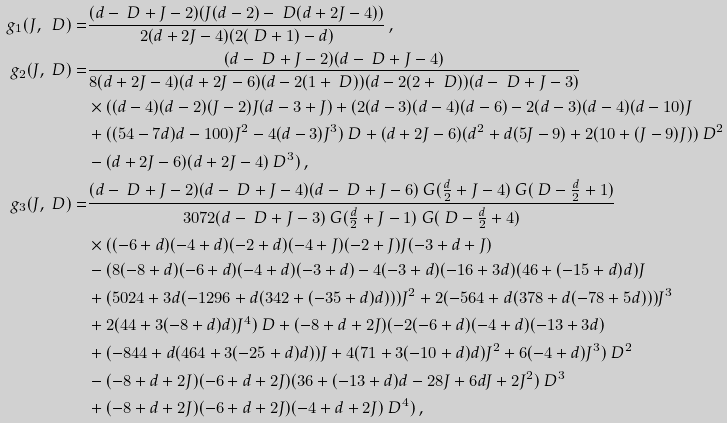Convert formula to latex. <formula><loc_0><loc_0><loc_500><loc_500>g _ { 1 } ( J , \ D ) = & \frac { ( d - \ D + J - 2 ) ( J ( d - 2 ) - \ D ( d + 2 J - 4 ) ) } { 2 ( d + 2 J - 4 ) ( 2 ( \ D + 1 ) - d ) } \, , \\ g _ { 2 } ( J , \ D ) = & \frac { ( d - \ D + J - 2 ) ( d - \ D + J - 4 ) } { 8 ( d + 2 J - 4 ) ( d + 2 J - 6 ) ( d - 2 ( 1 + \ D ) ) ( d - 2 ( 2 + \ D ) ) ( d - \ D + J - 3 ) } \\ & \times ( ( d - 4 ) ( d - 2 ) ( J - 2 ) J ( d - 3 + J ) + ( 2 ( d - 3 ) ( d - 4 ) ( d - 6 ) - 2 ( d - 3 ) ( d - 4 ) ( d - 1 0 ) J \\ & + ( ( 5 4 - 7 d ) d - 1 0 0 ) J ^ { 2 } - 4 ( d - 3 ) J ^ { 3 } ) \ D + ( d + 2 J - 6 ) ( d ^ { 2 } + d ( 5 J - 9 ) + 2 ( 1 0 + ( J - 9 ) J ) ) \ D ^ { 2 } \\ & - ( d + 2 J - 6 ) ( d + 2 J - 4 ) \ D ^ { 3 } ) \, , \\ g _ { 3 } ( J , \ D ) = & \frac { ( d - \ D + J - 2 ) ( d - \ D + J - 4 ) ( d - \ D + J - 6 ) \ G ( \frac { d } { 2 } + J - 4 ) \ G ( \ D - \frac { d } { 2 } + 1 ) } { 3 0 7 2 ( d - \ D + J - 3 ) \ G ( \frac { d } { 2 } + J - 1 ) \ G ( \ D - \frac { d } { 2 } + 4 ) } \\ & \times ( ( - 6 + d ) ( - 4 + d ) ( - 2 + d ) ( - 4 + J ) ( - 2 + J ) J ( - 3 + d + J ) \\ & - ( 8 ( - 8 + d ) ( - 6 + d ) ( - 4 + d ) ( - 3 + d ) - 4 ( - 3 + d ) ( - 1 6 + 3 d ) ( 4 6 + ( - 1 5 + d ) d ) J \\ & + ( 5 0 2 4 + 3 d ( - 1 2 9 6 + d ( 3 4 2 + ( - 3 5 + d ) d ) ) ) J ^ { 2 } + 2 ( - 5 6 4 + d ( 3 7 8 + d ( - 7 8 + 5 d ) ) ) J ^ { 3 } \\ & + 2 ( 4 4 + 3 ( - 8 + d ) d ) J ^ { 4 } ) \ D + ( - 8 + d + 2 J ) ( - 2 ( - 6 + d ) ( - 4 + d ) ( - 1 3 + 3 d ) \\ & + ( - 8 4 4 + d ( 4 6 4 + 3 ( - 2 5 + d ) d ) ) J + 4 ( 7 1 + 3 ( - 1 0 + d ) d ) J ^ { 2 } + 6 ( - 4 + d ) J ^ { 3 } ) \ D ^ { 2 } \\ & - ( - 8 + d + 2 J ) ( - 6 + d + 2 J ) ( 3 6 + ( - 1 3 + d ) d - 2 8 J + 6 d J + 2 J ^ { 2 } ) \ D ^ { 3 } \\ & + ( - 8 + d + 2 J ) ( - 6 + d + 2 J ) ( - 4 + d + 2 J ) \ D ^ { 4 } ) \, ,</formula> 